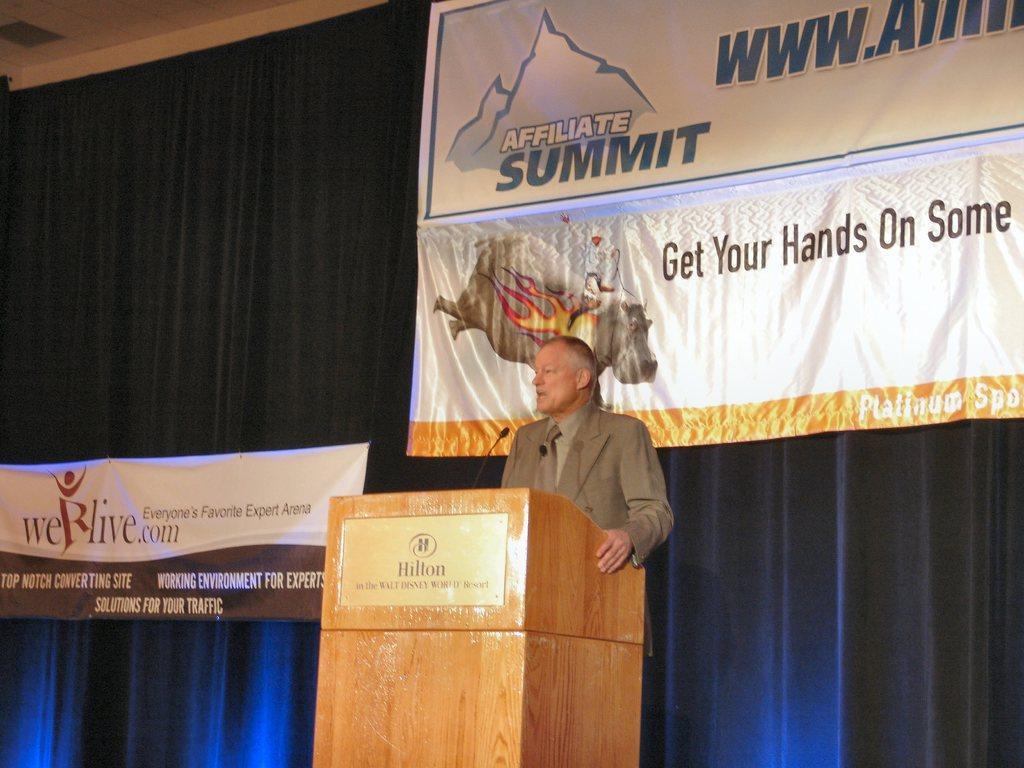Describe this image in one or two sentences. In the image there is a man standing behind a table and he is speaking something, in the background there are two banners and behind the banners there is a curtain. 